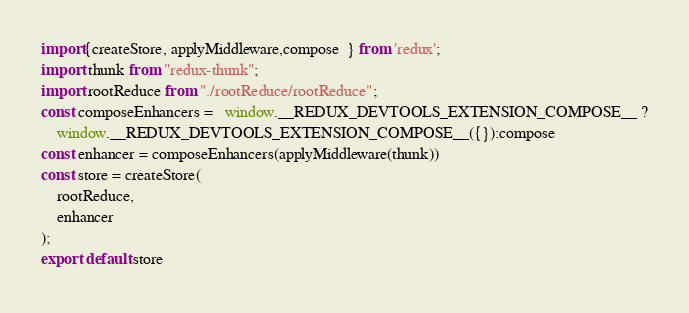<code> <loc_0><loc_0><loc_500><loc_500><_JavaScript_>import{createStore, applyMiddleware,compose  } from 'redux';
import thunk from "redux-thunk";
import rootReduce from "./rootReduce/rootReduce";
const composeEnhancers =   window.__REDUX_DEVTOOLS_EXTENSION_COMPOSE__ ?
    window.__REDUX_DEVTOOLS_EXTENSION_COMPOSE__({}):compose
const enhancer = composeEnhancers(applyMiddleware(thunk))
const store = createStore(
    rootReduce,
    enhancer
);
export default store

</code> 